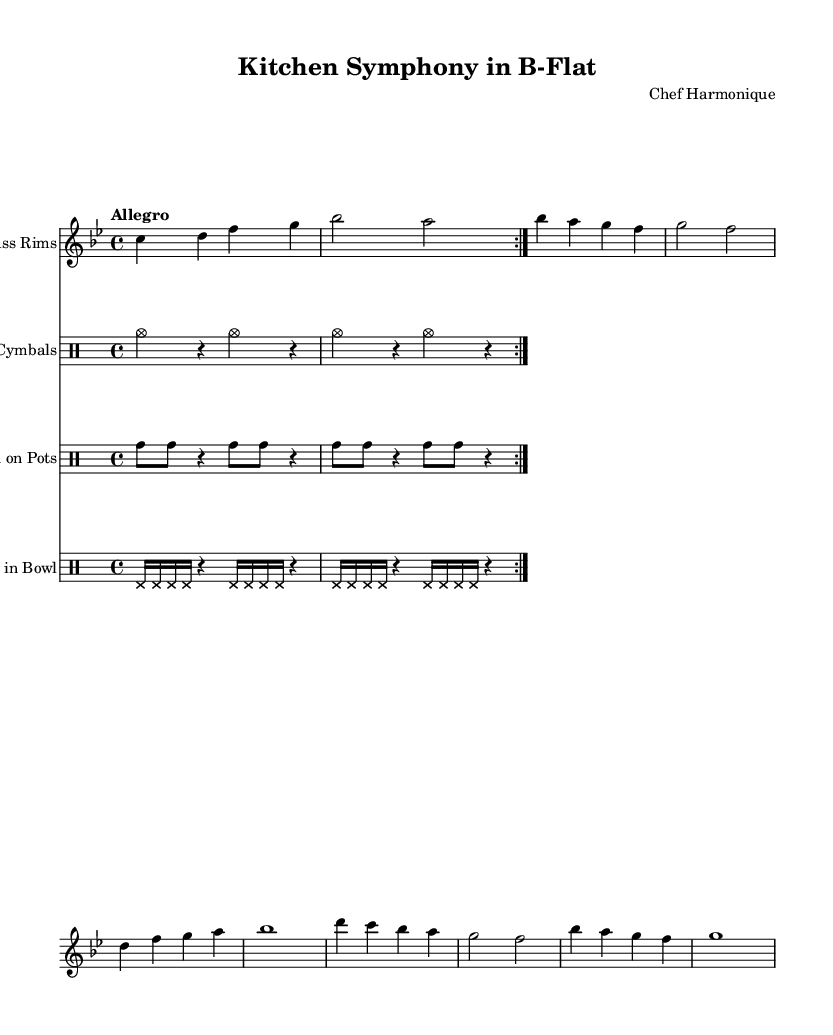What is the key signature of this music? The key signature is B-flat major, which has two flats (B-flat and E-flat). This can be determined by looking at the key signature indicated at the beginning of the music.
Answer: B-flat major What is the time signature of this music? The time signature is 4/4, as indicated at the beginning of the score. This means there are four beats per measure and the quarter note gets one beat.
Answer: 4/4 What is the tempo marking of this piece? The tempo marking is "Allegro," which indicates a fast-paced and lively performance. This is found in the tempo indication section of the sheet music.
Answer: Allegro How many different instrumental parts are present in this composition? There are four different instrumental parts: Pot Lid Cymbals, Wooden Spoon on Pots, Wine Glass Rims, and Whisk in Bowl. This can be observed from the different staves labeled for each instrument in the score.
Answer: Four Which instrument plays the melody in this piece? The melody is primarily played by the Wine Glass Rims, which is indicated by the treble clef and distinct melodic notes in the corresponding staff.
Answer: Wine Glass Rims What is the rhythmic pattern of the "Pot Lid Cymbals"? The rhythmic pattern consists of alternating hits on the cymbals with rests in between, notated with a pattern of four notes (cymc) followed by a rest. This can be seen in the drum notation for the "Pot Lid Cymbals."
Answer: Alternating hits with rests How does this composition challenge traditional musical norms? This composition utilizes everyday kitchen utensils as instruments, creating unique sounds and textures that are not typically found in traditional music. This experimental approach highlights creativity and redefines what can be considered music.
Answer: Utilizes kitchen utensils 